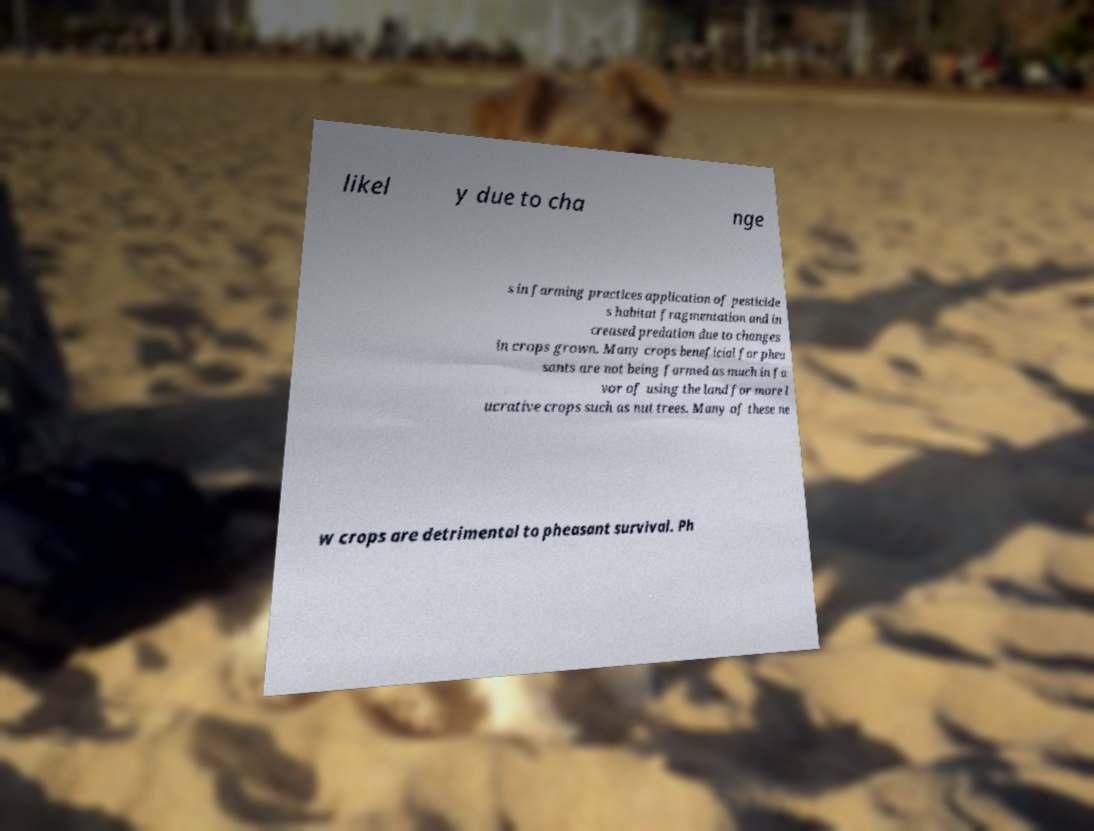What messages or text are displayed in this image? I need them in a readable, typed format. likel y due to cha nge s in farming practices application of pesticide s habitat fragmentation and in creased predation due to changes in crops grown. Many crops beneficial for phea sants are not being farmed as much in fa vor of using the land for more l ucrative crops such as nut trees. Many of these ne w crops are detrimental to pheasant survival. Ph 